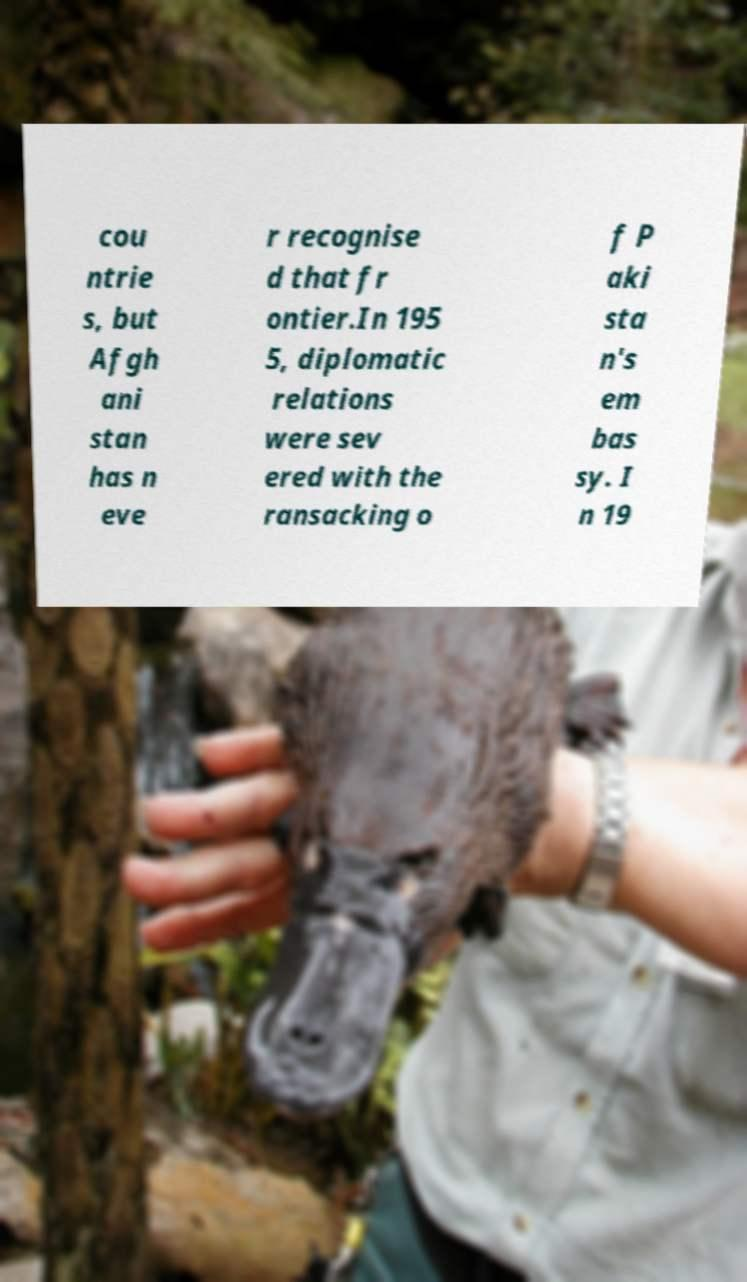There's text embedded in this image that I need extracted. Can you transcribe it verbatim? cou ntrie s, but Afgh ani stan has n eve r recognise d that fr ontier.In 195 5, diplomatic relations were sev ered with the ransacking o f P aki sta n's em bas sy. I n 19 